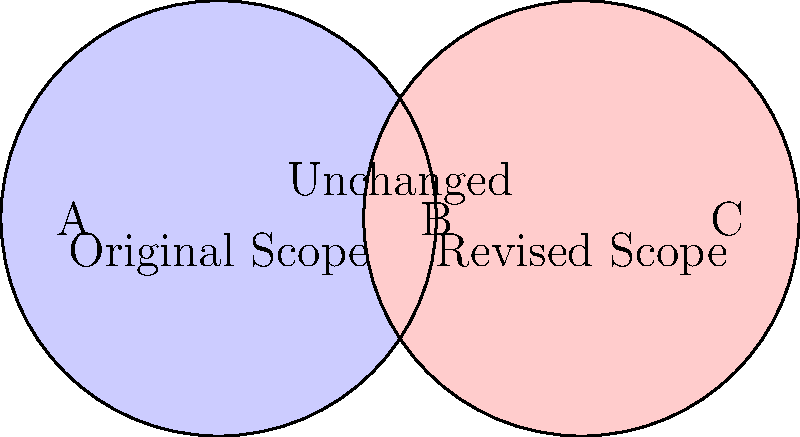In the Venn diagram above, circle A represents the original project scope, and circle B represents the revised project scope. What does area C represent in terms of project management? To answer this question, let's analyze the Venn diagram step by step:

1. Circle A represents the original project scope.
2. Circle B represents the revised project scope.
3. The overlapping area between A and B represents the unchanged scope, which are the requirements that remain the same in both the original and revised scope.
4. Area A that doesn't overlap with B represents the requirements that were in the original scope but have been removed in the revised scope.
5. Area B that doesn't overlap with A represents the new requirements added in the revised scope.
6. Area C, which is outside both circles, represents elements that are neither in the original scope nor in the revised scope.

Therefore, area C represents requirements or elements that were not included in either the original or the revised project scope. In project management terms, these could be considered out-of-scope items or potential future enhancements that are currently not part of the project.
Answer: Out-of-scope items 